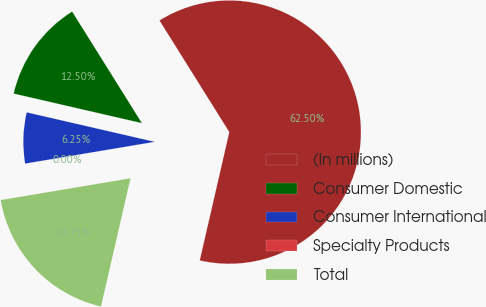Convert chart to OTSL. <chart><loc_0><loc_0><loc_500><loc_500><pie_chart><fcel>(In millions)<fcel>Consumer Domestic<fcel>Consumer International<fcel>Specialty Products<fcel>Total<nl><fcel>62.49%<fcel>12.5%<fcel>6.25%<fcel>0.0%<fcel>18.75%<nl></chart> 